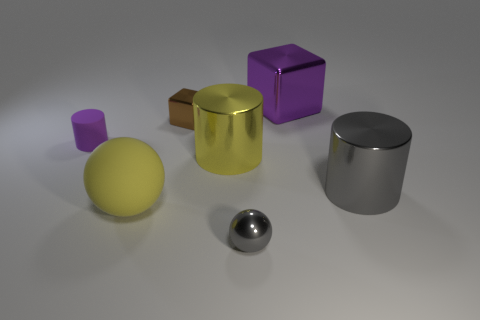Add 2 tiny gray metal things. How many objects exist? 9 Subtract all cylinders. How many objects are left? 4 Subtract all yellow metallic cylinders. Subtract all small purple things. How many objects are left? 5 Add 5 metallic cylinders. How many metallic cylinders are left? 7 Add 2 big green matte cylinders. How many big green matte cylinders exist? 2 Subtract 1 gray balls. How many objects are left? 6 